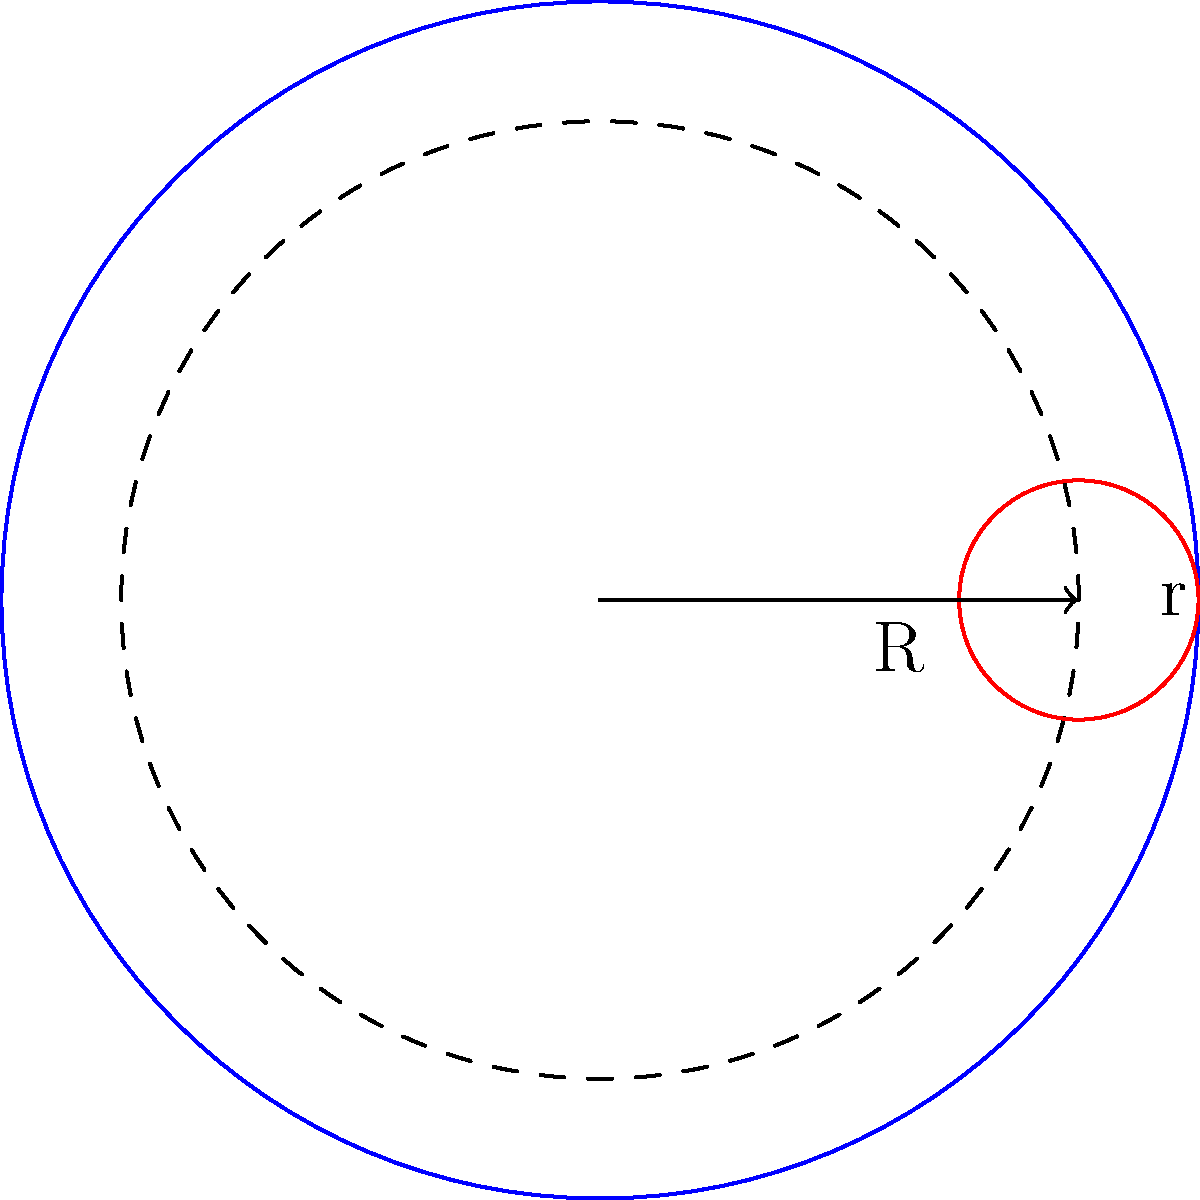In a circular film vault with radius R, you need to design an efficient storage system for cylindrical film reels with radius r. What is the maximum number of film reels that can be stored along the inner circumference of the vault, assuming they are placed tangent to each other and the vault wall? To solve this problem, we'll use analytic geometry concepts:

1) The centers of the film reels will form a circle with radius $(R-r)$, where $R$ is the radius of the vault and $r$ is the radius of each film reel.

2) The arc length between the centers of two adjacent reels is $2r$, as they are tangent to each other.

3) The number of reels that can fit is equal to the circumference of the circle formed by their centers divided by the arc length between adjacent reel centers:

   $n = \frac{2\pi(R-r)}{2r}$

4) Simplifying:
   
   $n = \frac{\pi(R-r)}{r}$

5) Since we need a whole number of reels, we round down to the nearest integer:

   $n = \lfloor\frac{\pi(R-r)}{r}\rfloor$

This formula gives us the maximum number of film reels that can be stored along the inner circumference of the vault.
Answer: $\lfloor\frac{\pi(R-r)}{r}\rfloor$ 